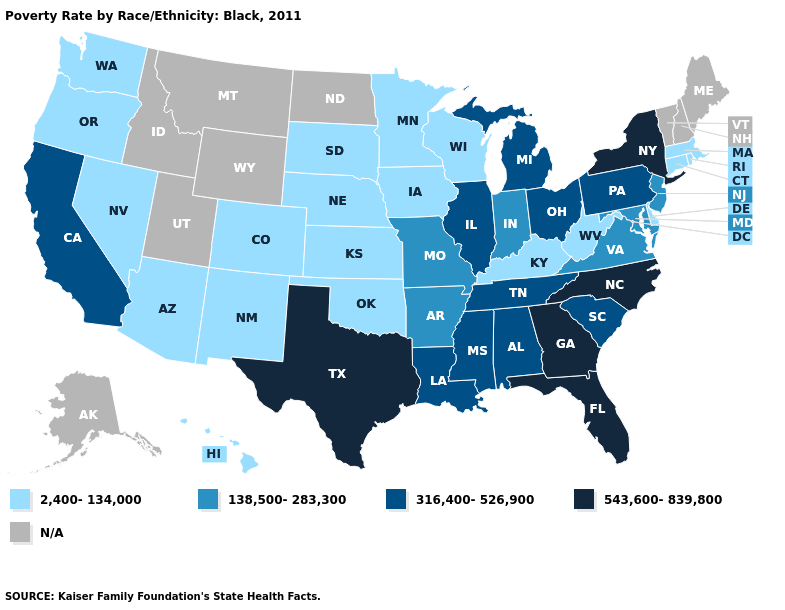What is the lowest value in states that border Nebraska?
Keep it brief. 2,400-134,000. What is the lowest value in the USA?
Quick response, please. 2,400-134,000. Name the states that have a value in the range 138,500-283,300?
Answer briefly. Arkansas, Indiana, Maryland, Missouri, New Jersey, Virginia. How many symbols are there in the legend?
Answer briefly. 5. Among the states that border Iowa , which have the lowest value?
Answer briefly. Minnesota, Nebraska, South Dakota, Wisconsin. Name the states that have a value in the range 138,500-283,300?
Give a very brief answer. Arkansas, Indiana, Maryland, Missouri, New Jersey, Virginia. What is the highest value in the MidWest ?
Be succinct. 316,400-526,900. Which states have the lowest value in the Northeast?
Write a very short answer. Connecticut, Massachusetts, Rhode Island. What is the highest value in the USA?
Quick response, please. 543,600-839,800. Name the states that have a value in the range 316,400-526,900?
Be succinct. Alabama, California, Illinois, Louisiana, Michigan, Mississippi, Ohio, Pennsylvania, South Carolina, Tennessee. What is the highest value in states that border Vermont?
Quick response, please. 543,600-839,800. What is the value of Alaska?
Short answer required. N/A. What is the highest value in states that border Pennsylvania?
Concise answer only. 543,600-839,800. What is the value of Kentucky?
Keep it brief. 2,400-134,000. Name the states that have a value in the range 543,600-839,800?
Give a very brief answer. Florida, Georgia, New York, North Carolina, Texas. 